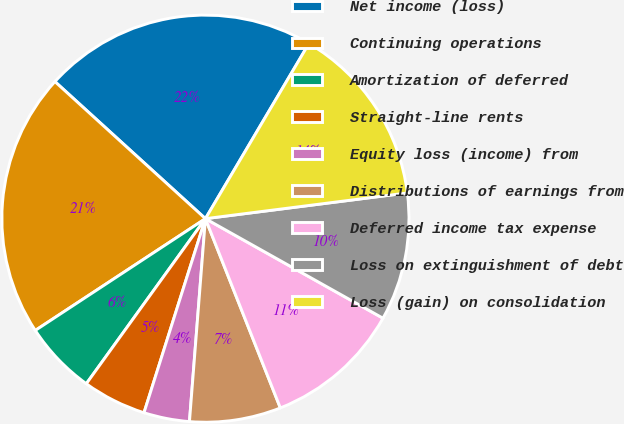Convert chart to OTSL. <chart><loc_0><loc_0><loc_500><loc_500><pie_chart><fcel>Net income (loss)<fcel>Continuing operations<fcel>Amortization of deferred<fcel>Straight-line rents<fcel>Equity loss (income) from<fcel>Distributions of earnings from<fcel>Deferred income tax expense<fcel>Loss on extinguishment of debt<fcel>Loss (gain) on consolidation<nl><fcel>21.74%<fcel>21.01%<fcel>5.8%<fcel>5.07%<fcel>3.63%<fcel>7.25%<fcel>10.87%<fcel>10.15%<fcel>14.49%<nl></chart> 